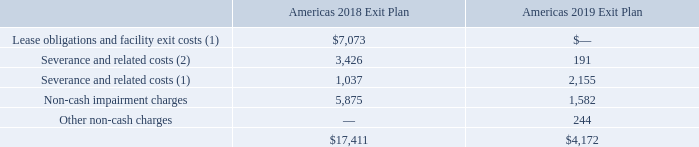Americas 2019 Exit Plan
During the first quarter of 2019, the Company initiated a restructuring plan to simplify and refine its operating model in the U.S. (the “Americas 2019 Exit Plan”), in part to improve agent attrition and absenteeism. The Americas 2019 Exit Plan included closing customer engagement centers, consolidating leased space in various locations in the U.S. and management reorganization. The Company finalized the actions as of September 30, 2019.
Americas 2018 Exit Plan
During the second quarter of 2018, the Company initiated a restructuring plan to manage and optimize capacity utilization, which included closing customer engagement centers and consolidating leased space in various locations in the U.S. and Canada (the “Americas 2018 Exit Plan”). The Company finalized the site closures under the Americas 2018 Exit Plan as of December 31, 2018, resulting in a reduction of 5,000 seats.
The Company’s actions under both the Americas 2018 and 2019 Exit Plans resulted in general and administrative cost savings and lower depreciation expense.
The cumulative costs incurred to date related to cash and non-cash expenditures resulting from the Americas 2018 and 2019 Exit Plans are outlined below as of December 31, 2019 (in thousands):
(1) Included in “General and administrative” costs in the accompanying Consolidated Statements of Operations.
(2) Included in “Direct salaries and related costs” in the accompanying Consolidated Statements of Operations.
The Company has paid a total of $12.3 million in cash through December 31, 2019, of which $10.4 million related to the Americas 2018 Exit Plan and $1.9 million related to the Americas 2019 Exit Plan.
How much has the Company paid in total in 2019? A total of $12.3 million in cash through december 31, 2019, of which $10.4 million related to the americas 2018 exit plan and $1.9 million related to the americas 2019 exit plan. Where are the Severance and related costs included in the accompanying Consolidated Statements of Operations? General and administrative, direct salaries and related costs. For which years is the Americas Exit Plan accounted for? 2019, 2018. In which year was Non-cash impairment charges larger? 5,875>1,582
Answer: 2018. What was the change in non-cash impairment charges in 2019 from 2018?
Answer scale should be: thousand. 1,582-5,875
Answer: -4293. What was the percentage change in non-cash impairment charges in 2019 from 2018?
Answer scale should be: percent. (1,582-5,875)/5,875
Answer: -73.07. 